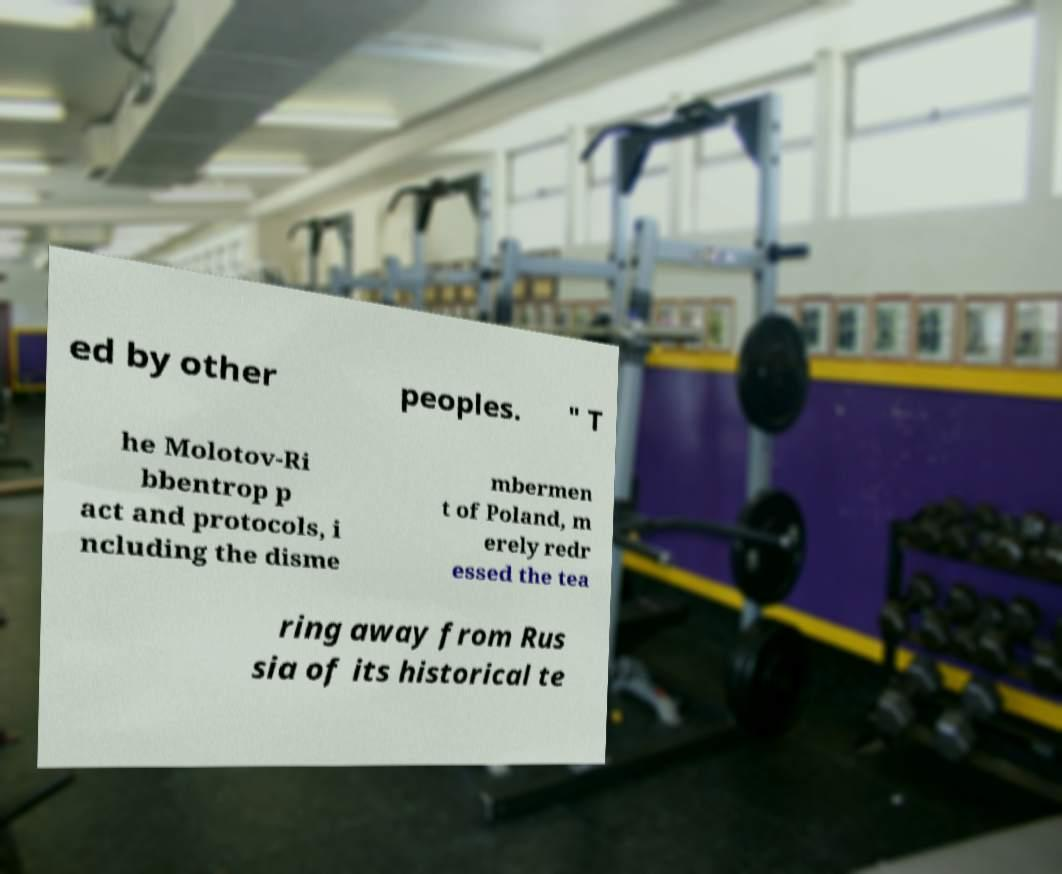For documentation purposes, I need the text within this image transcribed. Could you provide that? ed by other peoples. " T he Molotov-Ri bbentrop p act and protocols, i ncluding the disme mbermen t of Poland, m erely redr essed the tea ring away from Rus sia of its historical te 